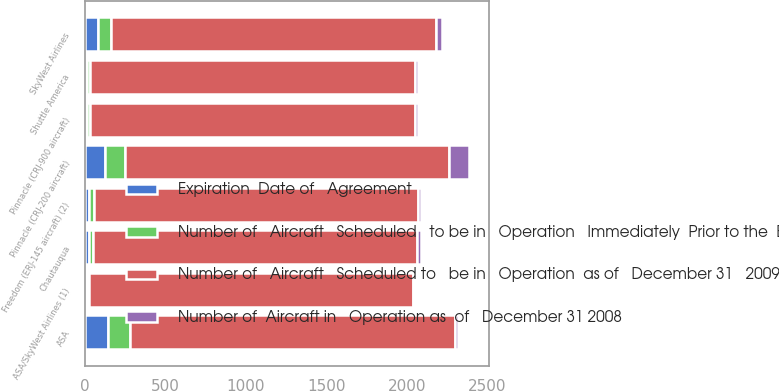<chart> <loc_0><loc_0><loc_500><loc_500><stacked_bar_chart><ecel><fcel>ASA<fcel>SkyWest Airlines<fcel>ASA/SkyWest Airlines (1)<fcel>Chautauqua<fcel>Freedom (ERJ-145 aircraft) (2)<fcel>Shuttle America<fcel>Pinnacle (CRJ-900 aircraft)<fcel>Pinnacle (CRJ-200 aircraft)<nl><fcel>Number of   Aircraft   Scheduled   to be in   Operation   Immediately  Prior to the  Expiration   of the   Agreement<fcel>141<fcel>80<fcel>12<fcel>24<fcel>28<fcel>16<fcel>18<fcel>124<nl><fcel>Expiration  Date of   Agreement<fcel>141<fcel>82<fcel>12<fcel>24<fcel>28<fcel>16<fcel>16<fcel>124<nl><fcel>Number of  Aircraft in   Operation as  of   December 31 2008<fcel>16<fcel>37<fcel>12<fcel>24<fcel>22<fcel>16<fcel>16<fcel>124<nl><fcel>Number of   Aircraft   Scheduled to   be in   Operation  as of   December 31   2009<fcel>2020<fcel>2020<fcel>2012<fcel>2016<fcel>2012<fcel>2019<fcel>2019<fcel>2017<nl></chart> 